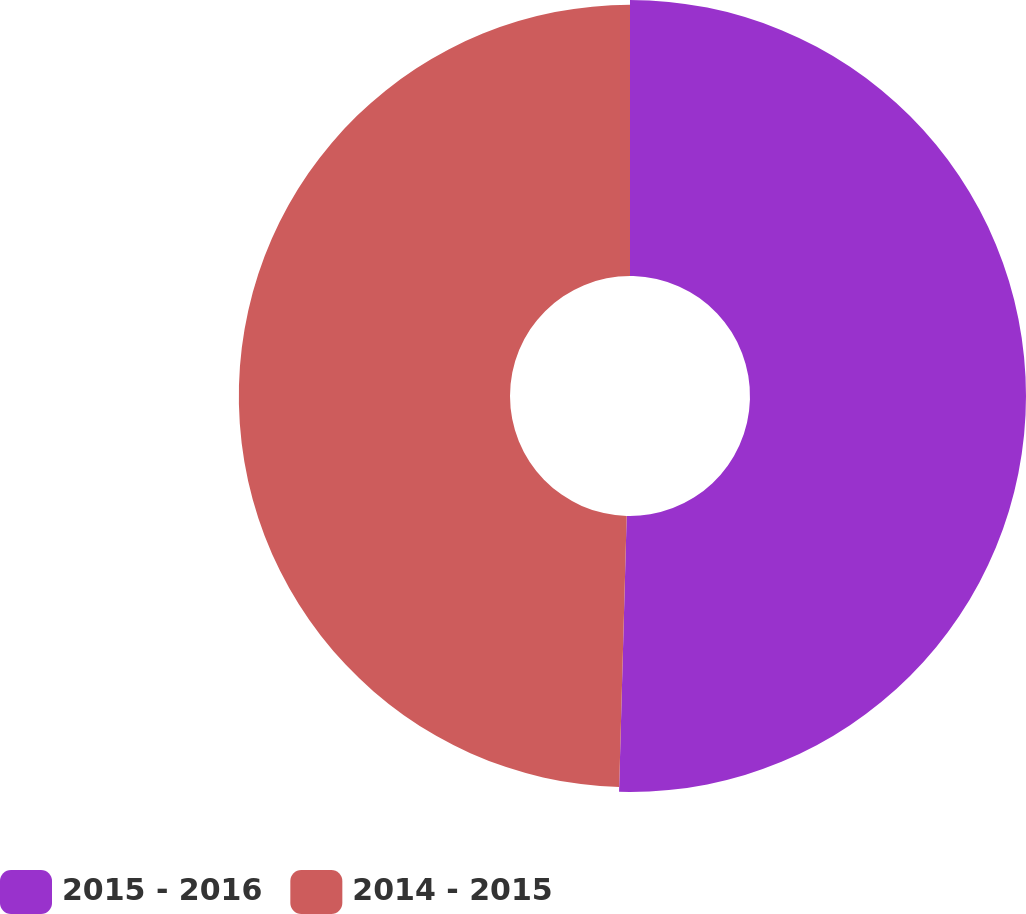<chart> <loc_0><loc_0><loc_500><loc_500><pie_chart><fcel>2015 - 2016<fcel>2014 - 2015<nl><fcel>50.44%<fcel>49.56%<nl></chart> 